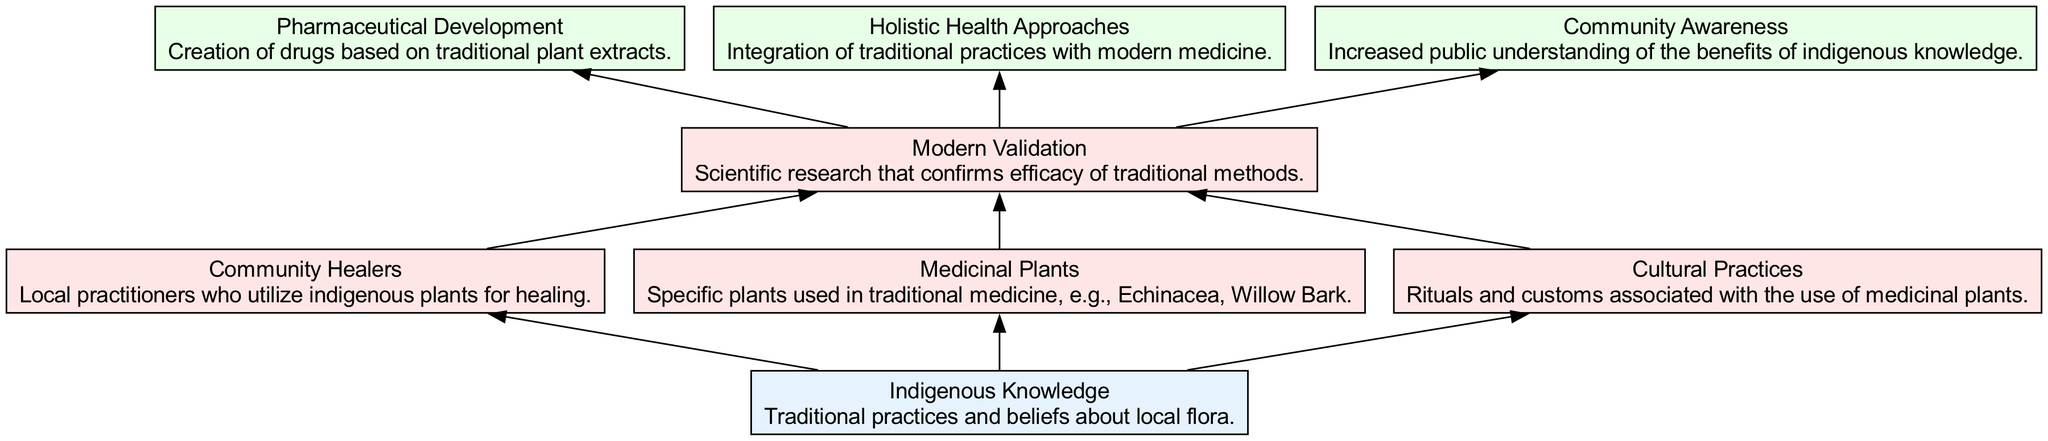What is the initial input in the diagram? The diagram begins with the node labeled "Indigenous Knowledge," which is classified as the input type. This indicates that the entire flow starts from this point.
Answer: Indigenous Knowledge How many processes are illustrated in the diagram? The diagram features four processes: "Community Healers," "Medicinal Plants," "Cultural Practices," and "Modern Validation." Counting these processes gives us the total amount.
Answer: 4 What are the outputs of the process "Modern Validation"? The diagram shows that "Modern Validation" connects to three output nodes: "Pharmaceutical Development," "Holistic Health Approaches," and "Community Awareness." By identifying these connections, we can specify the outputs.
Answer: Pharmaceutical Development, Holistic Health Approaches, Community Awareness Which node describes local practitioners? In the diagram, the node labeled "Community Healers" is designated to describe local practitioners who utilize indigenous plants for healing, providing a clear connection to their role in traditional medicine.
Answer: Community Healers What connects "Medicinal Plants" to "Modern Validation"? In the diagram, "Medicinal Plants" connects to "Modern Validation" through a direct edge or arrow, indicating that the knowledge of these plants contributes to the validation of traditional practices scientifically.
Answer: Direct edge How many edges are present in the entire diagram? The diagram displays a total of seven directed edges connecting various nodes, representing the relationships among the elements. This total can be calculated by counting all the arrows in the flow.
Answer: 7 What is the role of "Cultural Practices" in the diagram? The "Cultural Practices" node is shown to connect to "Modern Validation," indicating that these rituals and customs associated with medicinal plants contribute to the scientific verification of traditional methods.
Answer: Contributes to scientific verification Which process acts as the final output from the diagram? The diagram culminates in three outputs from the "Modern Validation" process, with "Pharmaceutical Development" being one of them, but it is not the final one since the outputs are on the same level. All are considered as final outputs simultaneously.
Answer: All outputs considered final 